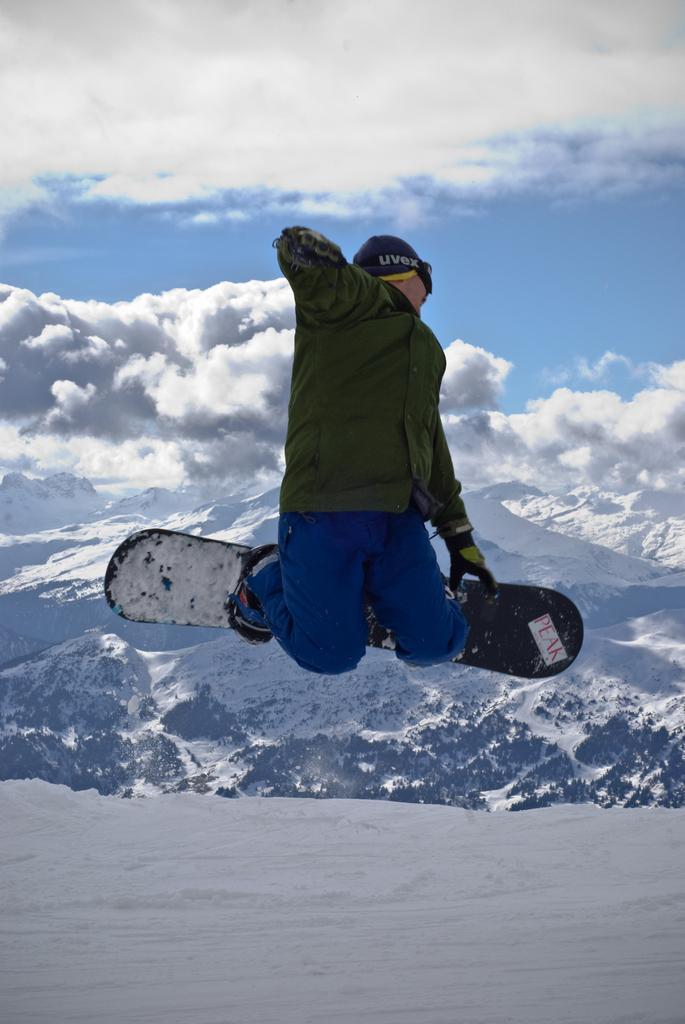How would you summarize this image in a sentence or two? In this image we can see a person jumping with ski board on his legs, also we can see the snow, mountains, and the cloudy sky. 